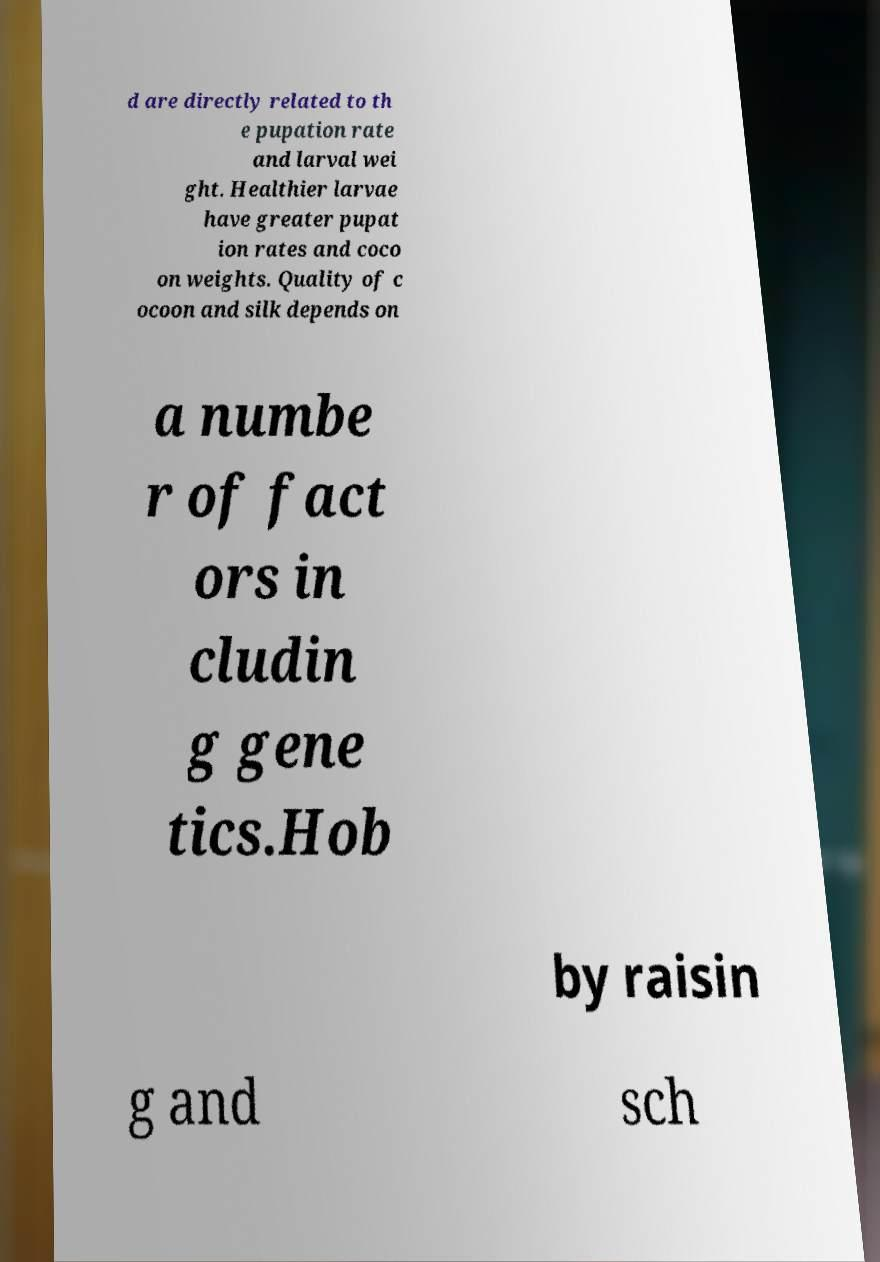Could you extract and type out the text from this image? d are directly related to th e pupation rate and larval wei ght. Healthier larvae have greater pupat ion rates and coco on weights. Quality of c ocoon and silk depends on a numbe r of fact ors in cludin g gene tics.Hob by raisin g and sch 